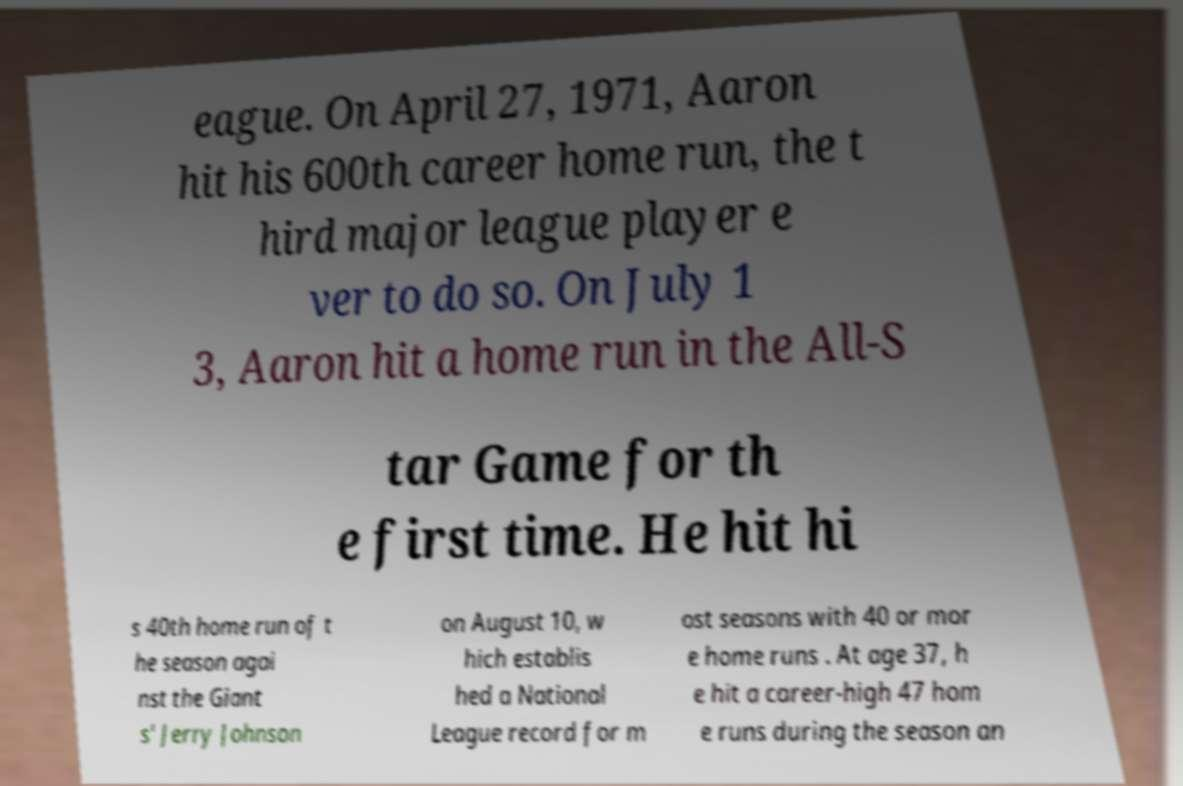For documentation purposes, I need the text within this image transcribed. Could you provide that? eague. On April 27, 1971, Aaron hit his 600th career home run, the t hird major league player e ver to do so. On July 1 3, Aaron hit a home run in the All-S tar Game for th e first time. He hit hi s 40th home run of t he season agai nst the Giant s' Jerry Johnson on August 10, w hich establis hed a National League record for m ost seasons with 40 or mor e home runs . At age 37, h e hit a career-high 47 hom e runs during the season an 